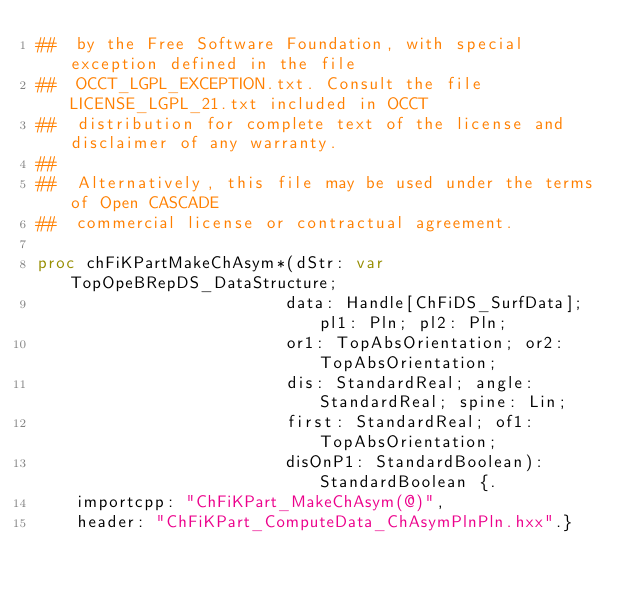<code> <loc_0><loc_0><loc_500><loc_500><_Nim_>##  by the Free Software Foundation, with special exception defined in the file
##  OCCT_LGPL_EXCEPTION.txt. Consult the file LICENSE_LGPL_21.txt included in OCCT
##  distribution for complete text of the license and disclaimer of any warranty.
##
##  Alternatively, this file may be used under the terms of Open CASCADE
##  commercial license or contractual agreement.

proc chFiKPartMakeChAsym*(dStr: var TopOpeBRepDS_DataStructure;
                         data: Handle[ChFiDS_SurfData]; pl1: Pln; pl2: Pln;
                         or1: TopAbsOrientation; or2: TopAbsOrientation;
                         dis: StandardReal; angle: StandardReal; spine: Lin;
                         first: StandardReal; of1: TopAbsOrientation;
                         disOnP1: StandardBoolean): StandardBoolean {.
    importcpp: "ChFiKPart_MakeChAsym(@)",
    header: "ChFiKPart_ComputeData_ChAsymPlnPln.hxx".}</code> 